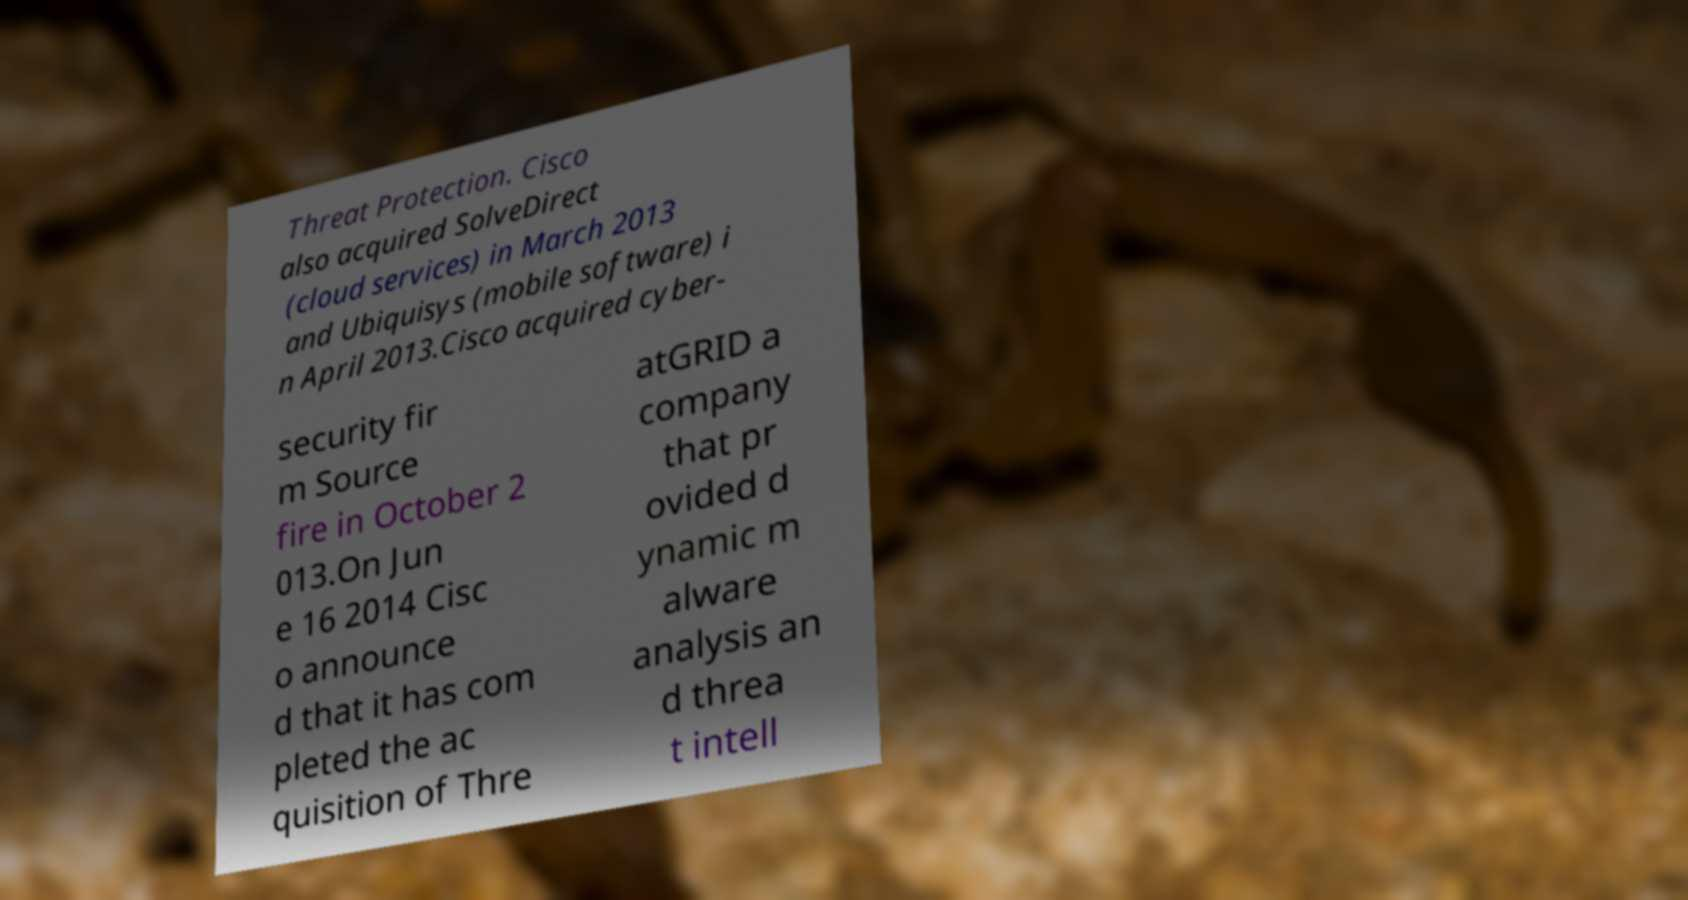For documentation purposes, I need the text within this image transcribed. Could you provide that? Threat Protection. Cisco also acquired SolveDirect (cloud services) in March 2013 and Ubiquisys (mobile software) i n April 2013.Cisco acquired cyber- security fir m Source fire in October 2 013.On Jun e 16 2014 Cisc o announce d that it has com pleted the ac quisition of Thre atGRID a company that pr ovided d ynamic m alware analysis an d threa t intell 